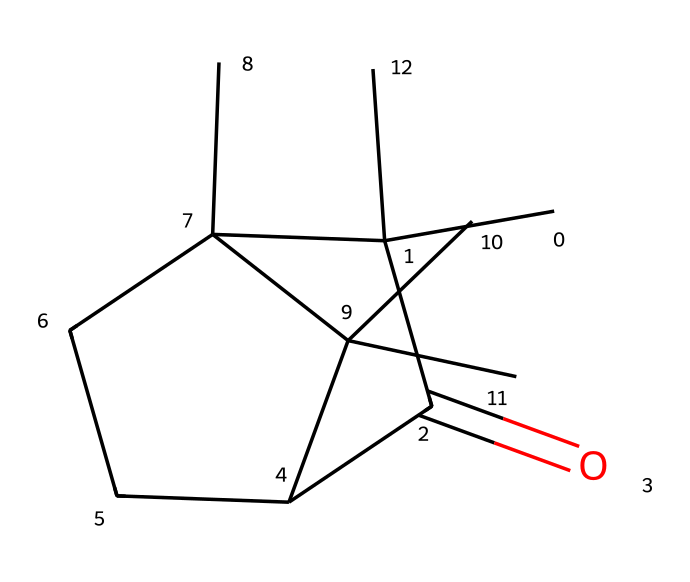How many carbon atoms are in camphor? To count the carbon atoms, observe the SMILES representation. Each "C" represents a carbon atom. By analyzing the structure encoded in the SMILES, there are 15 carbon atoms total.
Answer: 15 What is the functional group present in camphor? In the SMILES, there is a "C(=O)" which indicates the presence of a carbonyl group, characterizing it as a ketone.
Answer: ketone How many rings does camphor contain? By examining the structure, we see that the cyclic components in the SMILES suggest there are two fused cyclohexane rings.
Answer: 2 What is the total number of hydrogen atoms in camphor? To determine the number of hydrogen atoms, the general formula for saturated cycloalkanes is CnH2n. Camphor has 15 carbon atoms, so using the formula, we calculate 2(15) + 2 = 32 hydrogen atoms. However, due to the presence of the double bond (the carbonyl), we need to adjust that count to account for the fewer hydrogen atoms. Ultimately, there are 24 hydrogen atoms.
Answer: 24 What is a primary physical state of camphor at room temperature? The structure and molecular arrangement of camphor suggest a solid state at room temperature, as it is commonly found in a crystalline form.
Answer: solid How does the structure of camphor classify it as a cycloalkane? Camphor features multiple interconnected carbon atoms forming rings, which is characteristic of cycloalkanes. The presence of these fused cyclic structures confirms its classification.
Answer: cycloalkane 